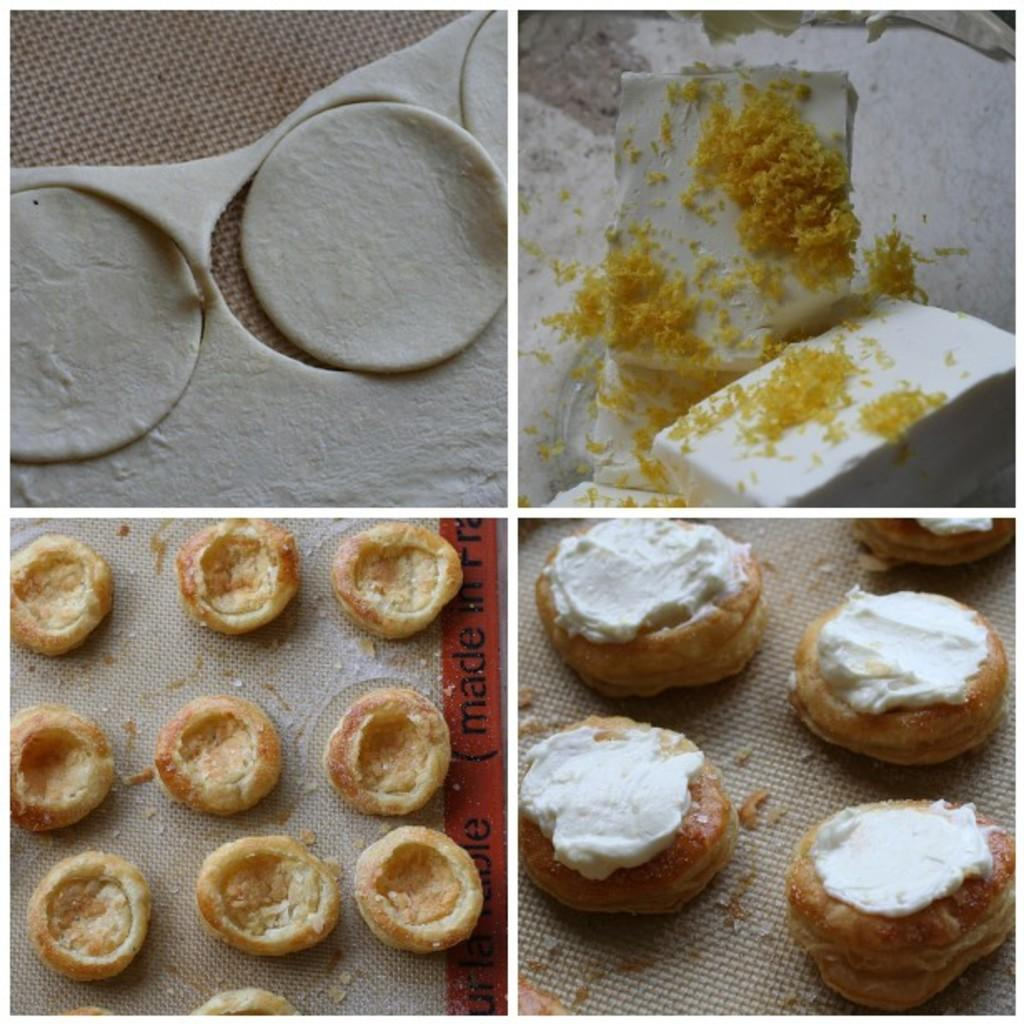What is the main theme of the image? The main theme of the image is a collage of food preparation steps. Can you describe the different steps shown in the collage? Unfortunately, the facts provided do not give specific details about the food preparation steps shown in the collage. However, we can infer that the collage likely includes various stages of preparing a meal or dish. How many screws can be seen in the image? There are no screws present in the image, as it is a collage of food preparation steps. Is there a spy observing the food preparation steps in the image? There is no indication of a spy or any person observing the food preparation steps in the image. 